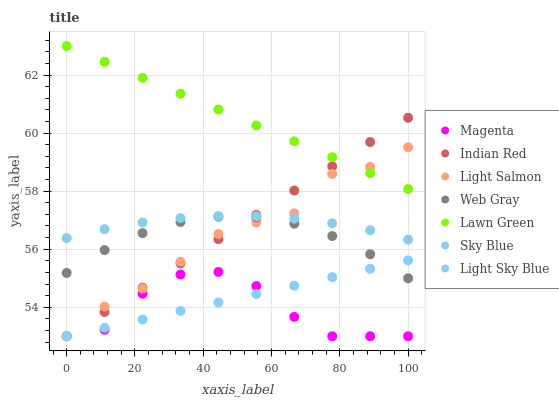Does Magenta have the minimum area under the curve?
Answer yes or no. Yes. Does Lawn Green have the maximum area under the curve?
Answer yes or no. Yes. Does Light Salmon have the minimum area under the curve?
Answer yes or no. No. Does Light Salmon have the maximum area under the curve?
Answer yes or no. No. Is Indian Red the smoothest?
Answer yes or no. Yes. Is Magenta the roughest?
Answer yes or no. Yes. Is Light Salmon the smoothest?
Answer yes or no. No. Is Light Salmon the roughest?
Answer yes or no. No. Does Light Salmon have the lowest value?
Answer yes or no. Yes. Does Web Gray have the lowest value?
Answer yes or no. No. Does Lawn Green have the highest value?
Answer yes or no. Yes. Does Light Salmon have the highest value?
Answer yes or no. No. Is Web Gray less than Lawn Green?
Answer yes or no. Yes. Is Lawn Green greater than Light Sky Blue?
Answer yes or no. Yes. Does Magenta intersect Light Salmon?
Answer yes or no. Yes. Is Magenta less than Light Salmon?
Answer yes or no. No. Is Magenta greater than Light Salmon?
Answer yes or no. No. Does Web Gray intersect Lawn Green?
Answer yes or no. No. 